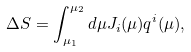Convert formula to latex. <formula><loc_0><loc_0><loc_500><loc_500>\Delta S = \int _ { \mu _ { 1 } } ^ { \mu _ { 2 } } d \mu J _ { i } ( \mu ) q ^ { i } ( \mu ) ,</formula> 